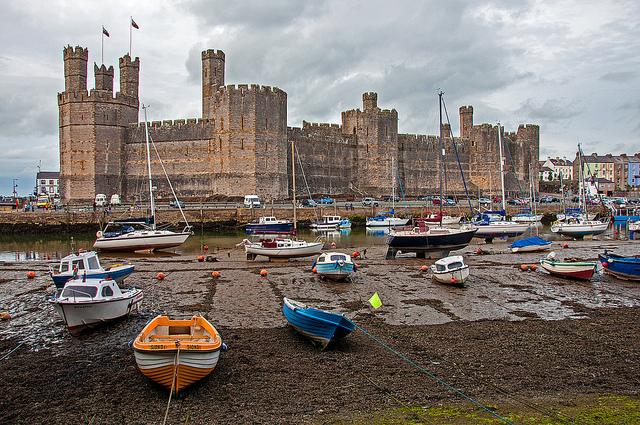How tall is the building?
Give a very brief answer. Very tall. How many boats are there?
Concise answer only. 23. What color is the boat on the left in front?
Short answer required. Orange. 